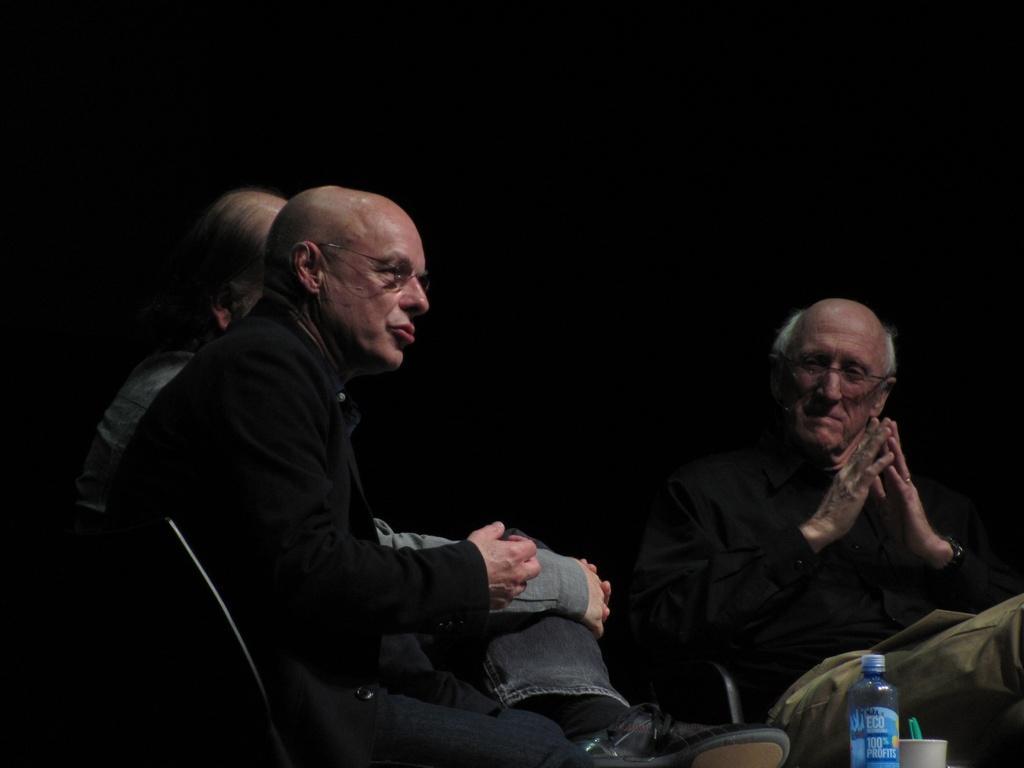Can you describe this image briefly? In this picture we can see three people sitting on the chairs in front of the table on which there is a bottle and la bowl and background is black in color. 